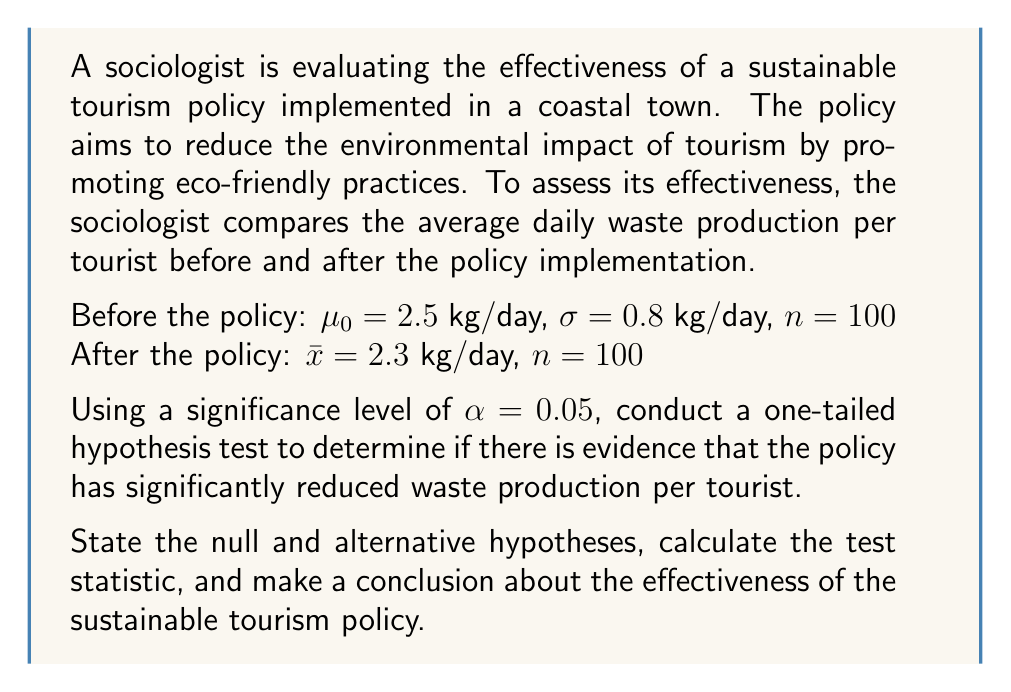Can you solve this math problem? Step 1: State the null and alternative hypotheses
$H_0: \mu \geq 2.5$ (The policy has not reduced waste production)
$H_a: \mu < 2.5$ (The policy has reduced waste production)

Step 2: Calculate the test statistic (z-score)
The formula for the z-score is:
$$z = \frac{\bar{x} - \mu_0}{\sigma / \sqrt{n}}$$

Substituting the values:
$$z = \frac{2.3 - 2.5}{0.8 / \sqrt{100}} = \frac{-0.2}{0.08} = -2.5$$

Step 3: Determine the critical value
For a one-tailed test with $\alpha = 0.05$, the critical z-value is -1.645.

Step 4: Compare the test statistic to the critical value
Since $-2.5 < -1.645$, we reject the null hypothesis.

Step 5: Calculate the p-value
Using a z-table or calculator, we find that the p-value for z = -2.5 is approximately 0.0062.

Step 6: Interpret the results
Since the p-value (0.0062) is less than the significance level (0.05), we reject the null hypothesis. There is strong evidence to suggest that the sustainable tourism policy has significantly reduced waste production per tourist.

Step 7: Conclusion
The statistical analysis supports the effectiveness of the sustainable tourism policy in reducing waste production. The sociologist can conclude that the policy has had a positive impact on environmental sustainability in the coastal town.
Answer: Reject $H_0$; policy effective (p-value = 0.0062 < 0.05) 